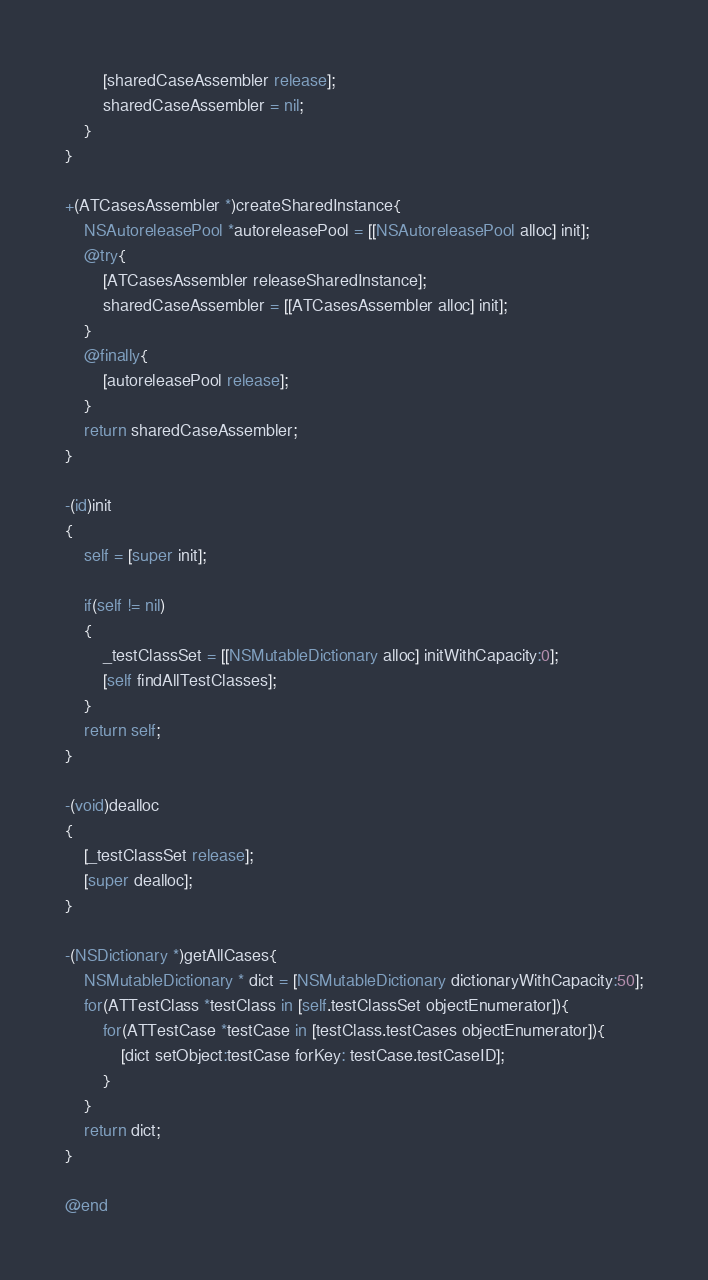<code> <loc_0><loc_0><loc_500><loc_500><_ObjectiveC_>        [sharedCaseAssembler release];
        sharedCaseAssembler = nil;
    }
}

+(ATCasesAssembler *)createSharedInstance{
    NSAutoreleasePool *autoreleasePool = [[NSAutoreleasePool alloc] init];
    @try{
        [ATCasesAssembler releaseSharedInstance];
        sharedCaseAssembler = [[ATCasesAssembler alloc] init];
    }
    @finally{
        [autoreleasePool release];
    }
    return sharedCaseAssembler;
}

-(id)init
{
    self = [super init];

	if(self != nil)
    {
        _testClassSet = [[NSMutableDictionary alloc] initWithCapacity:0];
        [self findAllTestClasses];
    }
    return self;
}

-(void)dealloc
{
    [_testClassSet release];
    [super dealloc];
}

-(NSDictionary *)getAllCases{
    NSMutableDictionary * dict = [NSMutableDictionary dictionaryWithCapacity:50];
    for(ATTestClass *testClass in [self.testClassSet objectEnumerator]){
        for(ATTestCase *testCase in [testClass.testCases objectEnumerator]){
            [dict setObject:testCase forKey: testCase.testCaseID];
        }
    }
    return dict;
}

@end
</code> 